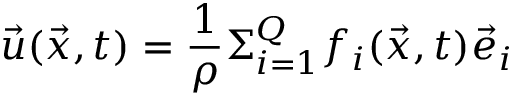<formula> <loc_0><loc_0><loc_500><loc_500>\vec { u } ( \vec { x } , t ) = \frac { 1 } { \rho } \Sigma _ { i = 1 } ^ { Q } f _ { i } ( \vec { x } , t ) \vec { e } _ { i }</formula> 